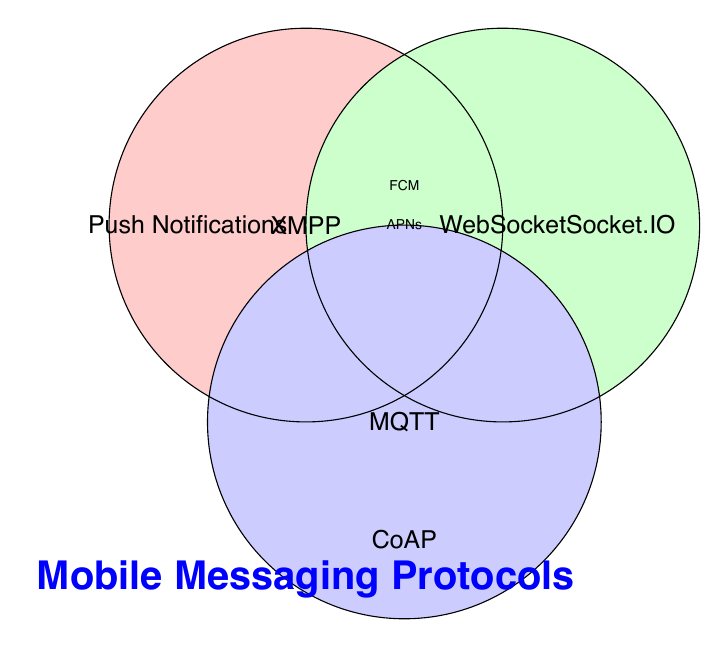What is the title of the figure? The title of the figure is located at the bottom in large, bold, blue text. It reads "Mobile Messaging Protocols."
Answer: Mobile Messaging Protocols Which category appears in all three circles? To determine this, identify which category label appears in the overlapping area of all three circles. The category "WebSocket" is shown in the overlapping area between all three circles (XMPP, WebSocket, and MQTT).
Answer: WebSocket How many protocols are listed outside the circles? The protocols listed outside the circles are "Push Notifications", "Socket.IO", and "CoAP". Count these protocols to get the answer.
Answer: 3 Which protocol is shared between XMPP and Push Notifications but is not in the MQTT circle? Look at the overlapping area between the XMPP circle and the Push Notifications category. The "Push Notifications" protocol appears in both XMPP and WebSocket, but not MQTT. Also, "WebSocket" is discarded as it's shared with MQTT too. Ultimately, "Push Notifications" within "Push Notifications" category is the answer.
Answer: Push Notifications What are the categories overlapping between the XMPP circle and the WebSocket but not with MQTT? Identify the overlapping area of XMPP and WebSocket circles while excluding the MQTT circle. They are "XMPP" and "WebSocket".
Answer: XMPP, WebSocket 